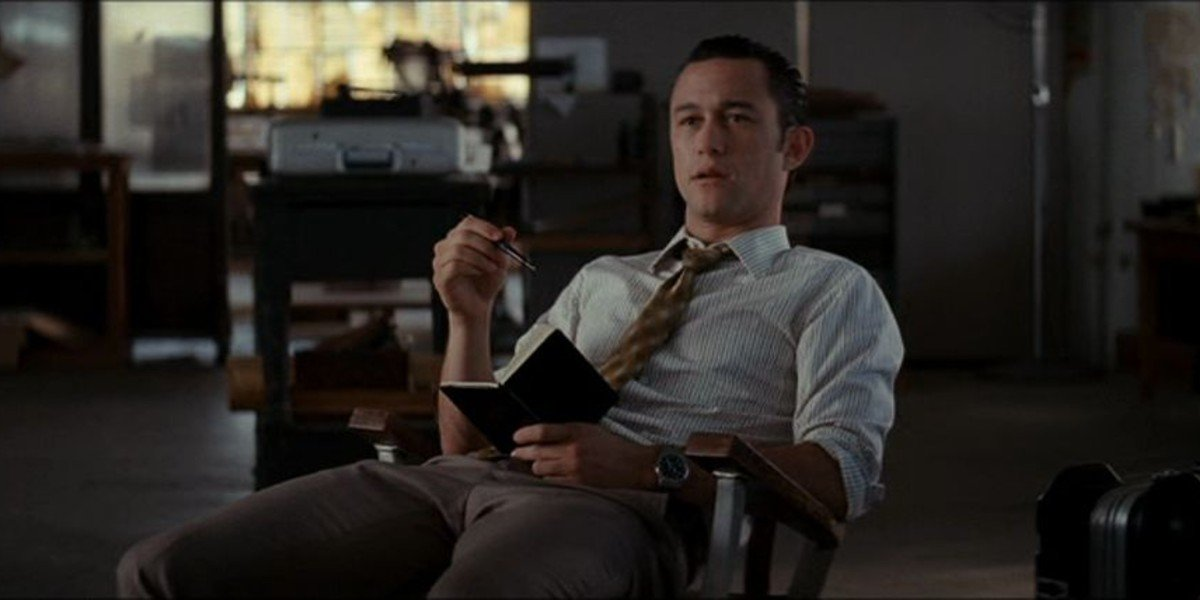Describe the office setting in more detail. The office setting is quite typical, with a desk positioned near a window that lets in natural light. On the desk, there appear to be various office supplies, perhaps a computer or documents. Behind him, vague outlines of office equipment and shelves can be seen, giving the sense of a busy and functional workspace. The suitcase to the side adds a dynamic element, hinting at travel or a busy schedule. 